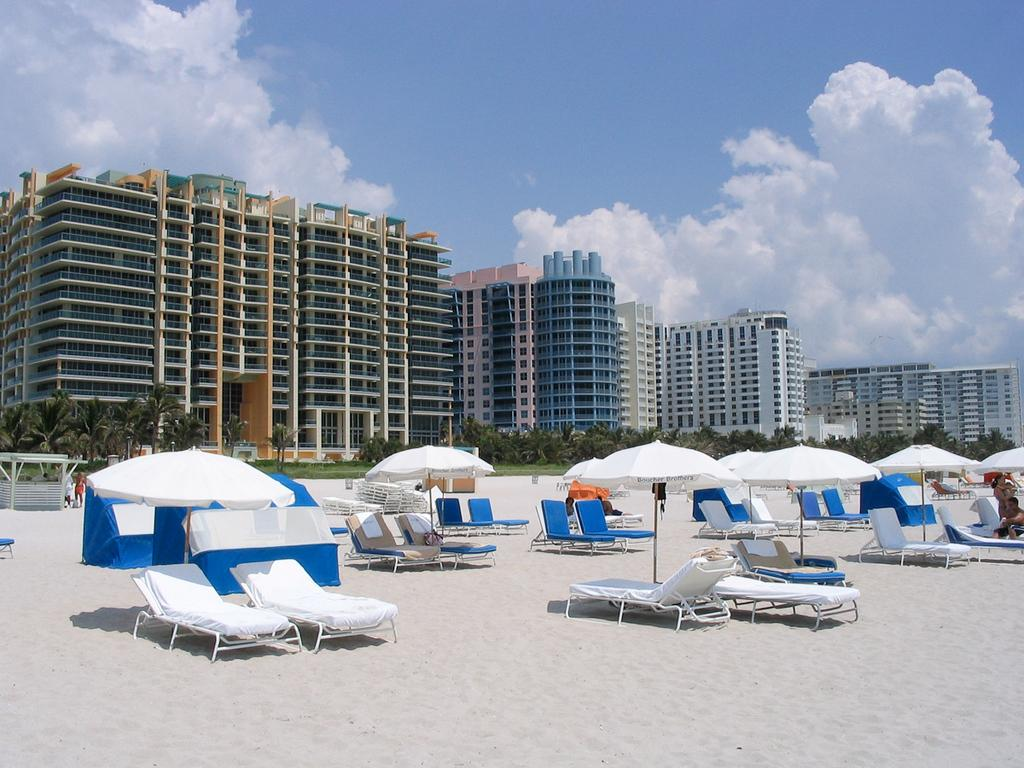What type of structures are located at the bottom of the image? There are shacks at the bottom of the image. What objects are present at the bottom of the image for shade or protection from the sun? There are umbrellas at the bottom of the image. What type of seating is available at the bottom of the image? There are chairs at the bottom of the image. What type of terrain is present at the bottom of the image? There is sand at the bottom of the image. What can be seen in the background of the image? There are trees, buildings, and the sky visible in the background of the image. What is the weather like in the image? The presence of clouds in the background of the image suggests that it might be partly cloudy. How many flocks of birds can be seen flying over the shacks in the image? There are no flocks of birds visible in the image. What type of loss is being experienced by the people in the image? There is no indication of any loss being experienced by the people in the image. 